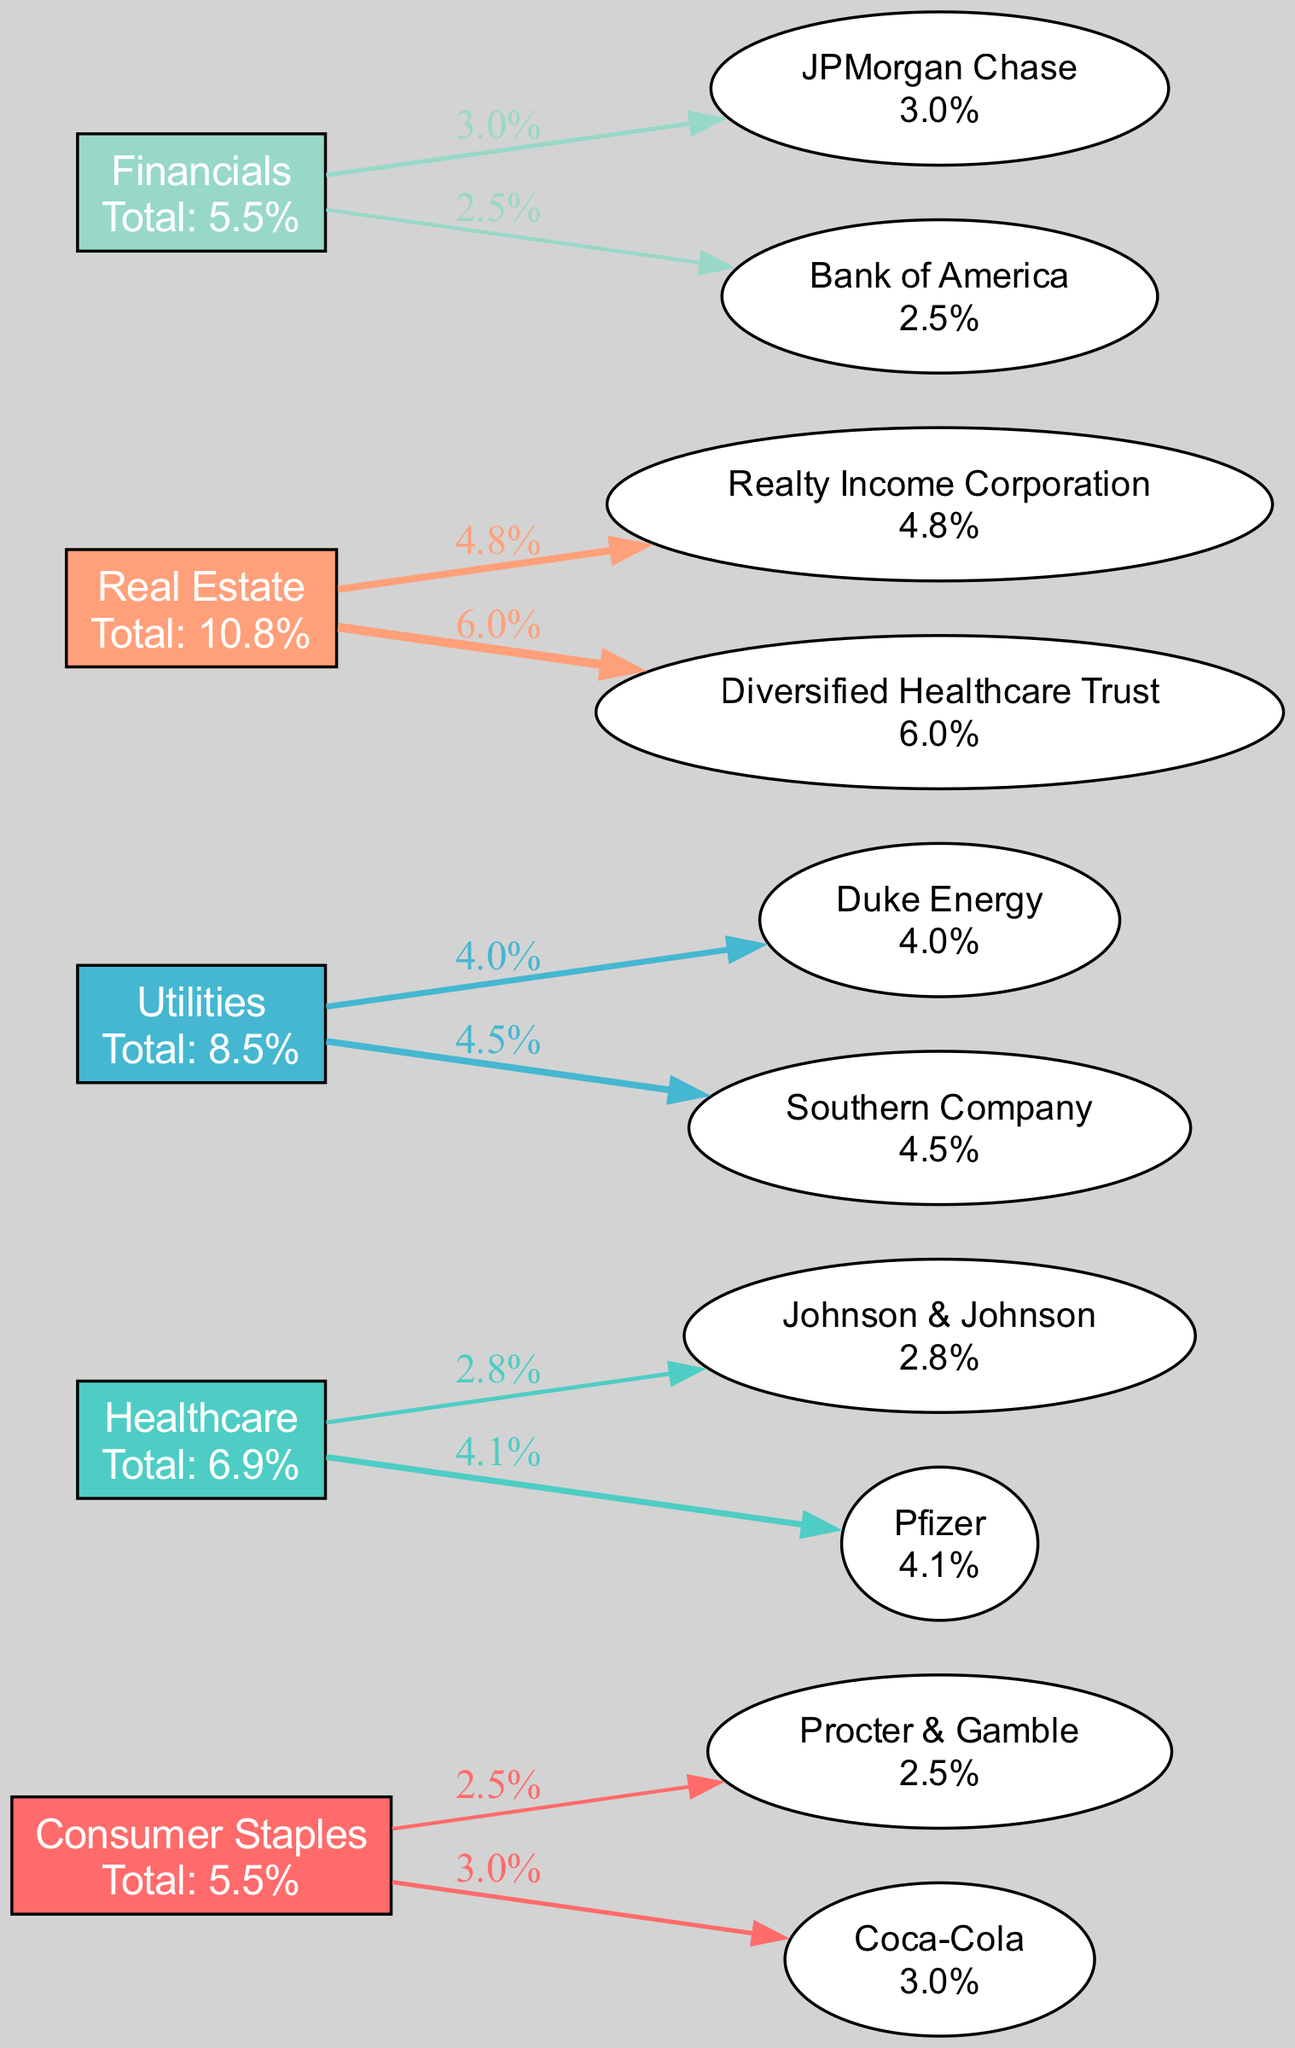What is the highest dividend yield among the companies in the diagram? Looking at the companies listed under each sector, the highest dividend yield is found in Diversified Healthcare Trust with a yield of 6.0%.
Answer: 6.0% Which sector has the most companies represented in the diagram? The diagram includes five sectors: Consumer Staples, Healthcare, Utilities, Real Estate, and Financials. Each sector has two companies represented, hence they all have the same number of companies.
Answer: Consumer Staples, Healthcare, Utilities, Real Estate, Financials What is the total dividend yield for the Utilities sector? To find the total yield for Utilities, we add the yields of Duke Energy (4.0%) and Southern Company (4.5%), which equals 8.5%.
Answer: 8.5% Which company has the lowest dividend yield in the diagram? Among the companies listed, Bank of America has the lowest dividend yield at 2.5%.
Answer: 2.5% What percentage of the total yield does Coca-Cola contribute to its sector? The total yield for the Consumer Staples sector is 5.5% (2.5% from Procter & Gamble and 3.0% from Coca-Cola). Therefore, Coca-Cola contributes 3.0% out of 5.5%, which is approximately 54.5%.
Answer: 54.5% Which sector generated the highest total dividend yield in the diagram? By adding up the total yields for each sector, the Real Estate sector has the highest total yield at 10.8%.
Answer: 10.8% How many edges are connected to the Duke Energy node? Duke Energy is connected to one edge leading from the Utilities sector, hence it has one edge connecting it.
Answer: 1 What color represents the Healthcare sector in the diagram? The Healthcare sector is represented by the second color in the defined palette, which is #4ECDC4 (a shade of teal).
Answer: Teal Which company's dividend yield is 4.1%? The diagram shows Pfizer with a dividend yield of 4.1%.
Answer: Pfizer 